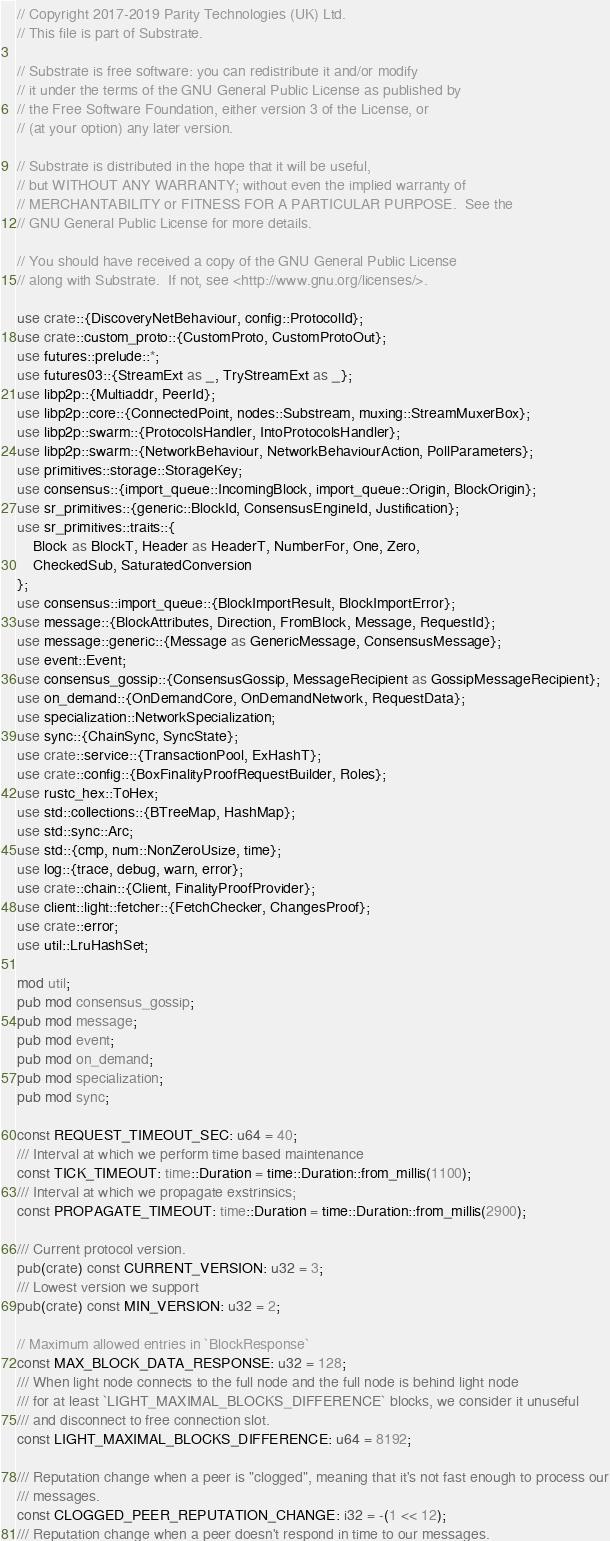Convert code to text. <code><loc_0><loc_0><loc_500><loc_500><_Rust_>// Copyright 2017-2019 Parity Technologies (UK) Ltd.
// This file is part of Substrate.

// Substrate is free software: you can redistribute it and/or modify
// it under the terms of the GNU General Public License as published by
// the Free Software Foundation, either version 3 of the License, or
// (at your option) any later version.

// Substrate is distributed in the hope that it will be useful,
// but WITHOUT ANY WARRANTY; without even the implied warranty of
// MERCHANTABILITY or FITNESS FOR A PARTICULAR PURPOSE.  See the
// GNU General Public License for more details.

// You should have received a copy of the GNU General Public License
// along with Substrate.  If not, see <http://www.gnu.org/licenses/>.

use crate::{DiscoveryNetBehaviour, config::ProtocolId};
use crate::custom_proto::{CustomProto, CustomProtoOut};
use futures::prelude::*;
use futures03::{StreamExt as _, TryStreamExt as _};
use libp2p::{Multiaddr, PeerId};
use libp2p::core::{ConnectedPoint, nodes::Substream, muxing::StreamMuxerBox};
use libp2p::swarm::{ProtocolsHandler, IntoProtocolsHandler};
use libp2p::swarm::{NetworkBehaviour, NetworkBehaviourAction, PollParameters};
use primitives::storage::StorageKey;
use consensus::{import_queue::IncomingBlock, import_queue::Origin, BlockOrigin};
use sr_primitives::{generic::BlockId, ConsensusEngineId, Justification};
use sr_primitives::traits::{
	Block as BlockT, Header as HeaderT, NumberFor, One, Zero,
	CheckedSub, SaturatedConversion
};
use consensus::import_queue::{BlockImportResult, BlockImportError};
use message::{BlockAttributes, Direction, FromBlock, Message, RequestId};
use message::generic::{Message as GenericMessage, ConsensusMessage};
use event::Event;
use consensus_gossip::{ConsensusGossip, MessageRecipient as GossipMessageRecipient};
use on_demand::{OnDemandCore, OnDemandNetwork, RequestData};
use specialization::NetworkSpecialization;
use sync::{ChainSync, SyncState};
use crate::service::{TransactionPool, ExHashT};
use crate::config::{BoxFinalityProofRequestBuilder, Roles};
use rustc_hex::ToHex;
use std::collections::{BTreeMap, HashMap};
use std::sync::Arc;
use std::{cmp, num::NonZeroUsize, time};
use log::{trace, debug, warn, error};
use crate::chain::{Client, FinalityProofProvider};
use client::light::fetcher::{FetchChecker, ChangesProof};
use crate::error;
use util::LruHashSet;

mod util;
pub mod consensus_gossip;
pub mod message;
pub mod event;
pub mod on_demand;
pub mod specialization;
pub mod sync;

const REQUEST_TIMEOUT_SEC: u64 = 40;
/// Interval at which we perform time based maintenance
const TICK_TIMEOUT: time::Duration = time::Duration::from_millis(1100);
/// Interval at which we propagate exstrinsics;
const PROPAGATE_TIMEOUT: time::Duration = time::Duration::from_millis(2900);

/// Current protocol version.
pub(crate) const CURRENT_VERSION: u32 = 3;
/// Lowest version we support
pub(crate) const MIN_VERSION: u32 = 2;

// Maximum allowed entries in `BlockResponse`
const MAX_BLOCK_DATA_RESPONSE: u32 = 128;
/// When light node connects to the full node and the full node is behind light node
/// for at least `LIGHT_MAXIMAL_BLOCKS_DIFFERENCE` blocks, we consider it unuseful
/// and disconnect to free connection slot.
const LIGHT_MAXIMAL_BLOCKS_DIFFERENCE: u64 = 8192;

/// Reputation change when a peer is "clogged", meaning that it's not fast enough to process our
/// messages.
const CLOGGED_PEER_REPUTATION_CHANGE: i32 = -(1 << 12);
/// Reputation change when a peer doesn't respond in time to our messages.</code> 